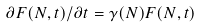Convert formula to latex. <formula><loc_0><loc_0><loc_500><loc_500>\partial F ( N , t ) / \partial t = \gamma ( N ) F ( N , t )</formula> 